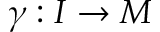Convert formula to latex. <formula><loc_0><loc_0><loc_500><loc_500>\gamma \colon I \rightarrow M</formula> 